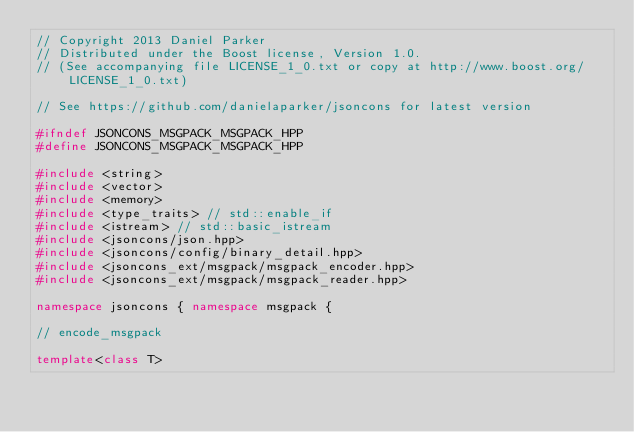Convert code to text. <code><loc_0><loc_0><loc_500><loc_500><_C++_>// Copyright 2013 Daniel Parker
// Distributed under the Boost license, Version 1.0.
// (See accompanying file LICENSE_1_0.txt or copy at http://www.boost.org/LICENSE_1_0.txt)

// See https://github.com/danielaparker/jsoncons for latest version

#ifndef JSONCONS_MSGPACK_MSGPACK_HPP
#define JSONCONS_MSGPACK_MSGPACK_HPP

#include <string>
#include <vector>
#include <memory>
#include <type_traits> // std::enable_if
#include <istream> // std::basic_istream
#include <jsoncons/json.hpp>
#include <jsoncons/config/binary_detail.hpp>
#include <jsoncons_ext/msgpack/msgpack_encoder.hpp>
#include <jsoncons_ext/msgpack/msgpack_reader.hpp>

namespace jsoncons { namespace msgpack {

// encode_msgpack

template<class T></code> 